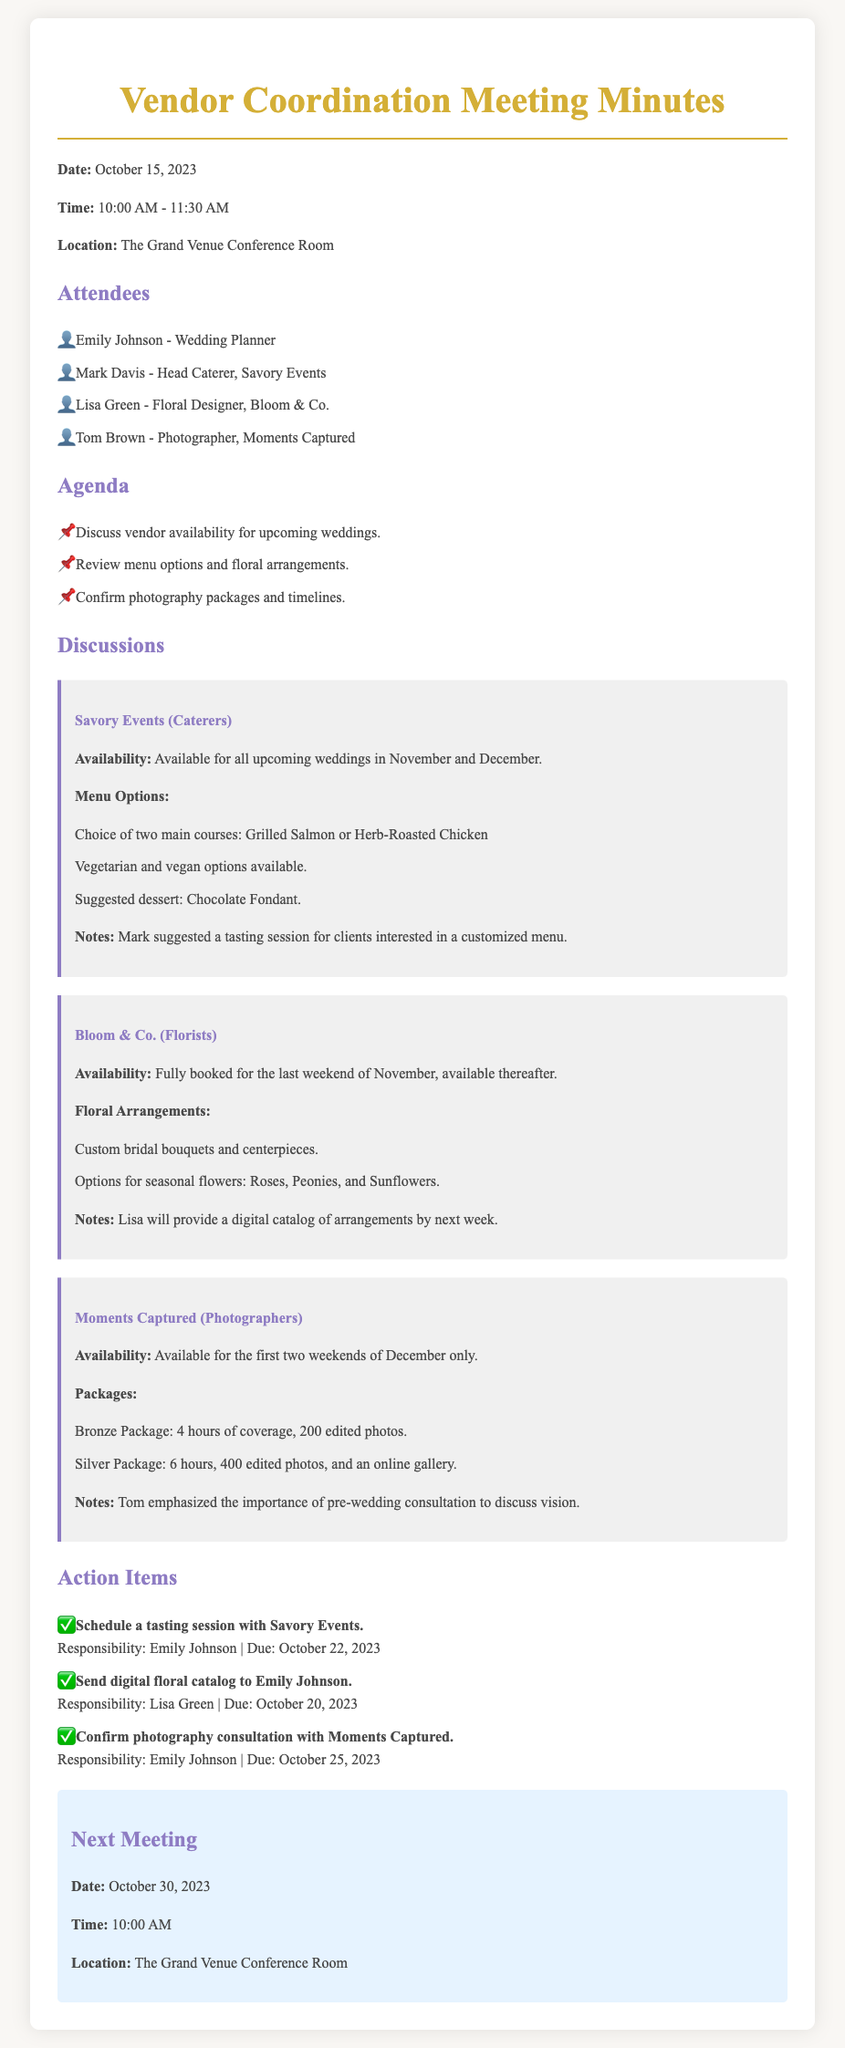what is the date of the meeting? The document states that the meeting took place on October 15, 2023.
Answer: October 15, 2023 who was the head caterer at the meeting? The meeting notes mention Mark Davis as the Head Caterer from Savory Events.
Answer: Mark Davis which florist is fully booked for the last weekend of November? The document indicates that Bloom & Co. is fully booked for the last weekend of November.
Answer: Bloom & Co what is the due date for sending the digital floral catalog? The action item specifies that the digital floral catalog should be sent by Lisa Green by October 20, 2023.
Answer: October 20, 2023 how many photography packages were discussed in the meeting? There are two photography packages mentioned: Bronze Package and Silver Package, as outlined in the document.
Answer: Two what is the name of the venue where the next meeting will be held? The document specifies that the next meeting will occur at The Grand Venue Conference Room.
Answer: The Grand Venue Conference Room what is the suggested dessert from Savory Events? The meeting notes mention that the suggested dessert is Chocolate Fondant from Savory Events.
Answer: Chocolate Fondant what is the responsibility for scheduling the tasting session? The action item states that Emily Johnson is responsible for scheduling the tasting session with Savory Events.
Answer: Emily Johnson when is the next scheduled meeting? The document states that the next meeting is scheduled for October 30, 2023.
Answer: October 30, 2023 